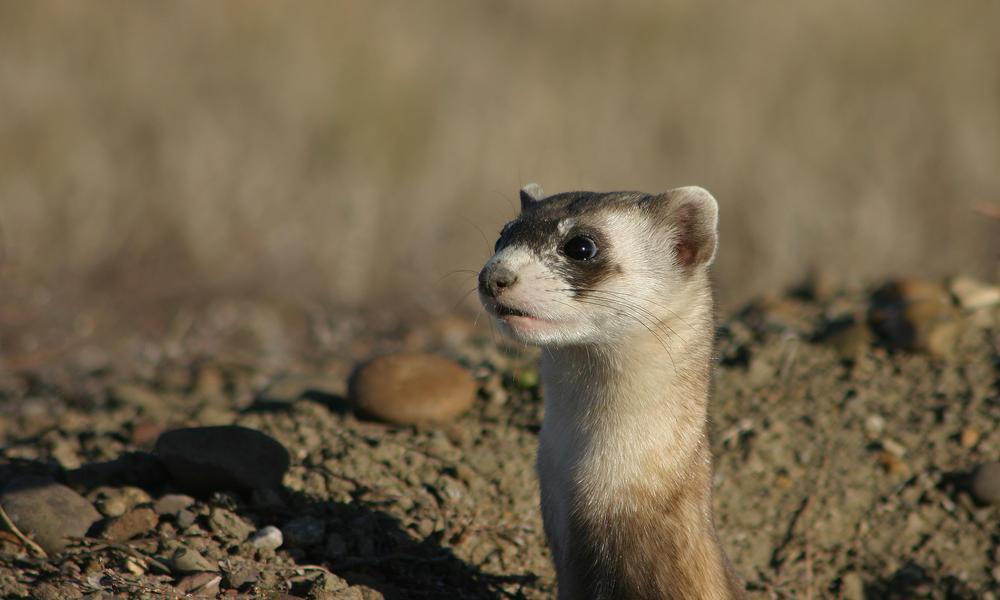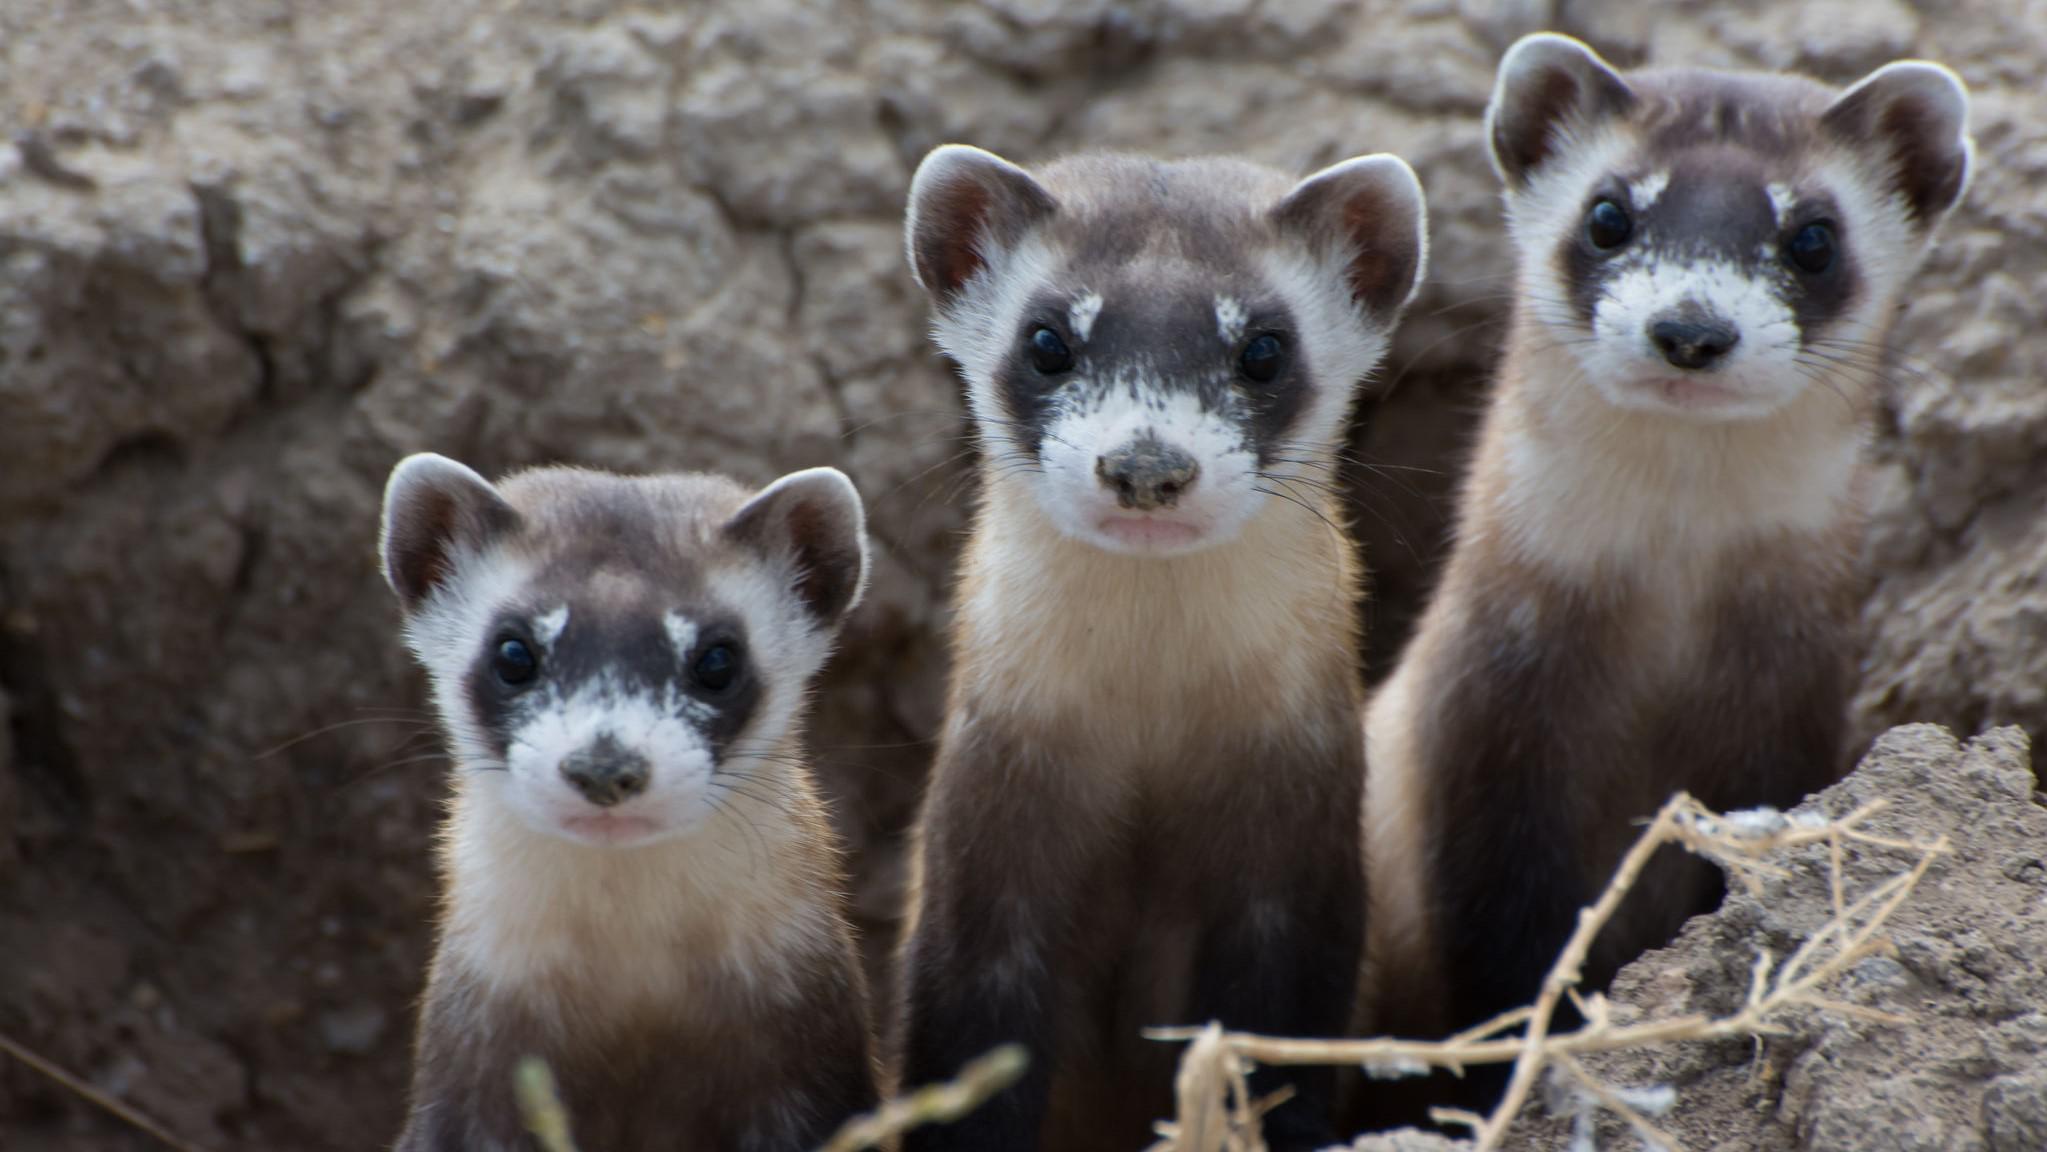The first image is the image on the left, the second image is the image on the right. Examine the images to the left and right. Is the description "Prairie dogs pose together in the image on the right." accurate? Answer yes or no. Yes. The first image is the image on the left, the second image is the image on the right. Analyze the images presented: Is the assertion "Right image shows at least one camera-facing ferret with upright body, emerging from a hole." valid? Answer yes or no. Yes. 